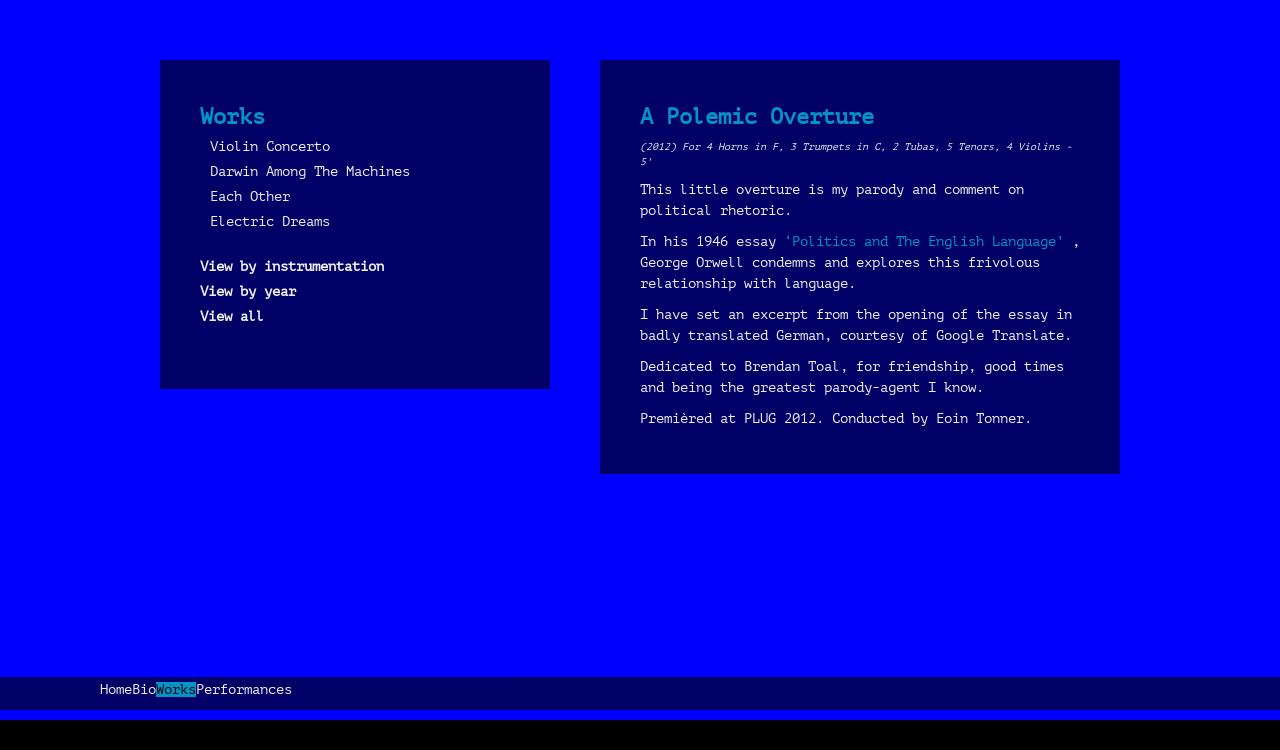Can you explain more about the theme of the 'A Polemic Overture' section displayed in the image? The 'A Polemic Overture' section in the image discusses a musical piece by Richard Greer, which serves as a commentary on political rhetoric. The musical piece uses an ensemble including horns, trumpets, tubas, tenors, and violins, creating a diverse soundscape. The composer's intent to parody political dialogue is expressed through a satirical adaptation of George Orwell's essay, emphasizing the often trivial use of language in politics. 